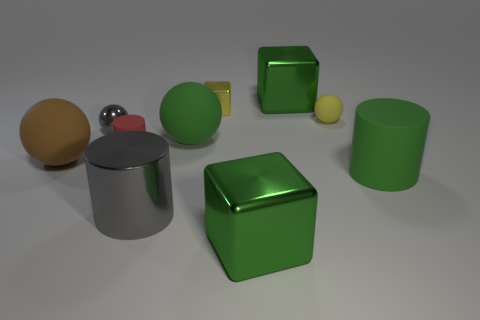Subtract all yellow spheres. How many spheres are left? 3 Subtract all red balls. Subtract all purple cubes. How many balls are left? 4 Subtract all cylinders. How many objects are left? 7 Add 6 brown objects. How many brown objects are left? 7 Add 7 yellow shiny objects. How many yellow shiny objects exist? 8 Subtract 0 purple blocks. How many objects are left? 10 Subtract all green objects. Subtract all metallic cubes. How many objects are left? 3 